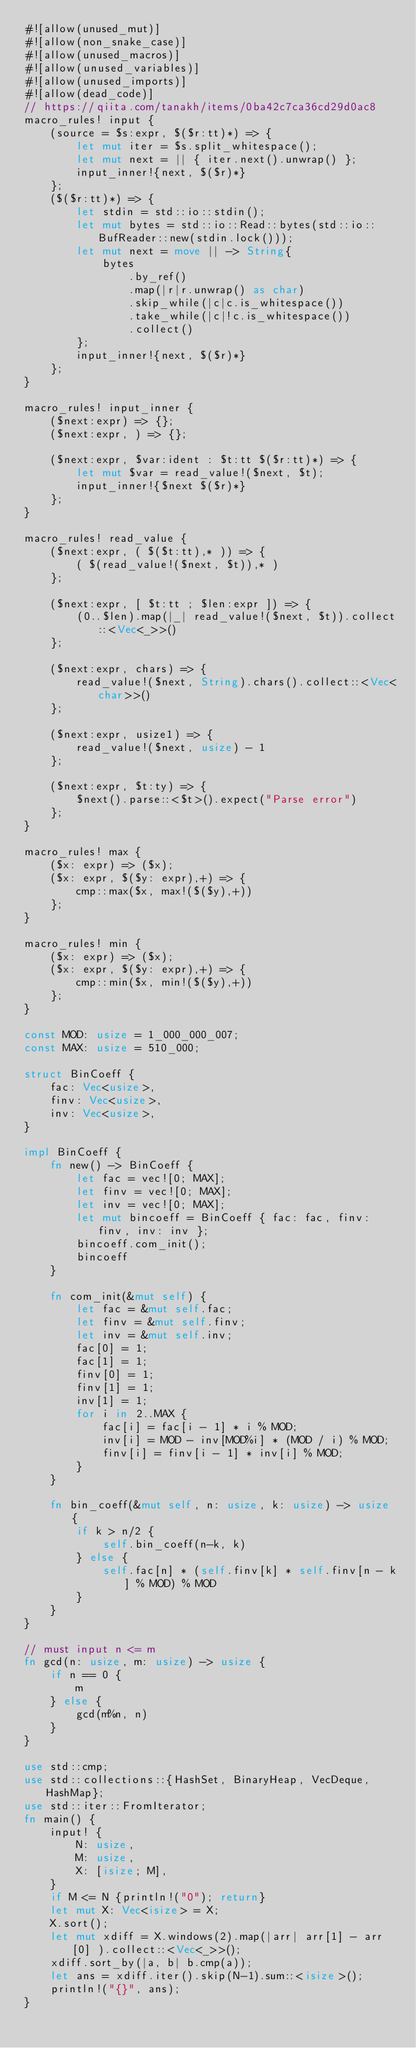<code> <loc_0><loc_0><loc_500><loc_500><_Rust_>#![allow(unused_mut)]
#![allow(non_snake_case)]
#![allow(unused_macros)]
#![allow(unused_variables)]
#![allow(unused_imports)]
#![allow(dead_code)]
// https://qiita.com/tanakh/items/0ba42c7ca36cd29d0ac8
macro_rules! input {
    (source = $s:expr, $($r:tt)*) => {
        let mut iter = $s.split_whitespace();
        let mut next = || { iter.next().unwrap() };
        input_inner!{next, $($r)*}
    };
    ($($r:tt)*) => {
        let stdin = std::io::stdin();
        let mut bytes = std::io::Read::bytes(std::io::BufReader::new(stdin.lock()));
        let mut next = move || -> String{
            bytes
                .by_ref()
                .map(|r|r.unwrap() as char)
                .skip_while(|c|c.is_whitespace())
                .take_while(|c|!c.is_whitespace())
                .collect()
        };
        input_inner!{next, $($r)*}
    };
}

macro_rules! input_inner {
    ($next:expr) => {};
    ($next:expr, ) => {};

    ($next:expr, $var:ident : $t:tt $($r:tt)*) => {
        let mut $var = read_value!($next, $t);
        input_inner!{$next $($r)*}
    };
}

macro_rules! read_value {
    ($next:expr, ( $($t:tt),* )) => {
        ( $(read_value!($next, $t)),* )
    };

    ($next:expr, [ $t:tt ; $len:expr ]) => {
        (0..$len).map(|_| read_value!($next, $t)).collect::<Vec<_>>()
    };

    ($next:expr, chars) => {
        read_value!($next, String).chars().collect::<Vec<char>>()
    };

    ($next:expr, usize1) => {
        read_value!($next, usize) - 1
    };

    ($next:expr, $t:ty) => {
        $next().parse::<$t>().expect("Parse error")
    };
}

macro_rules! max {
    ($x: expr) => ($x);
    ($x: expr, $($y: expr),+) => {
        cmp::max($x, max!($($y),+))
    };
}

macro_rules! min {
    ($x: expr) => ($x);
    ($x: expr, $($y: expr),+) => {
        cmp::min($x, min!($($y),+))
    };
}

const MOD: usize = 1_000_000_007;
const MAX: usize = 510_000;

struct BinCoeff {
    fac: Vec<usize>,
    finv: Vec<usize>,
    inv: Vec<usize>,
}

impl BinCoeff {
    fn new() -> BinCoeff {
        let fac = vec![0; MAX];
        let finv = vec![0; MAX];
        let inv = vec![0; MAX];
        let mut bincoeff = BinCoeff { fac: fac, finv: finv, inv: inv };
        bincoeff.com_init();
        bincoeff
    }

    fn com_init(&mut self) {
        let fac = &mut self.fac;
        let finv = &mut self.finv;
        let inv = &mut self.inv;
        fac[0] = 1;
        fac[1] = 1;
        finv[0] = 1;
        finv[1] = 1;
        inv[1] = 1;
        for i in 2..MAX {
            fac[i] = fac[i - 1] * i % MOD;
            inv[i] = MOD - inv[MOD%i] * (MOD / i) % MOD;
            finv[i] = finv[i - 1] * inv[i] % MOD;
        }
    }

    fn bin_coeff(&mut self, n: usize, k: usize) -> usize {
        if k > n/2 {
            self.bin_coeff(n-k, k)
        } else {
            self.fac[n] * (self.finv[k] * self.finv[n - k] % MOD) % MOD
        }
    }
}

// must input n <= m
fn gcd(n: usize, m: usize) -> usize {
    if n == 0 {
        m
    } else {
        gcd(m%n, n)
    }
}

use std::cmp;
use std::collections::{HashSet, BinaryHeap, VecDeque, HashMap};
use std::iter::FromIterator;
fn main() {
    input! {
        N: usize,
        M: usize,
        X: [isize; M],
    }
    if M <= N {println!("0"); return}
    let mut X: Vec<isize> = X;
    X.sort();
    let mut xdiff = X.windows(2).map(|arr| arr[1] - arr[0] ).collect::<Vec<_>>();
    xdiff.sort_by(|a, b| b.cmp(a));
    let ans = xdiff.iter().skip(N-1).sum::<isize>();
    println!("{}", ans);
}</code> 